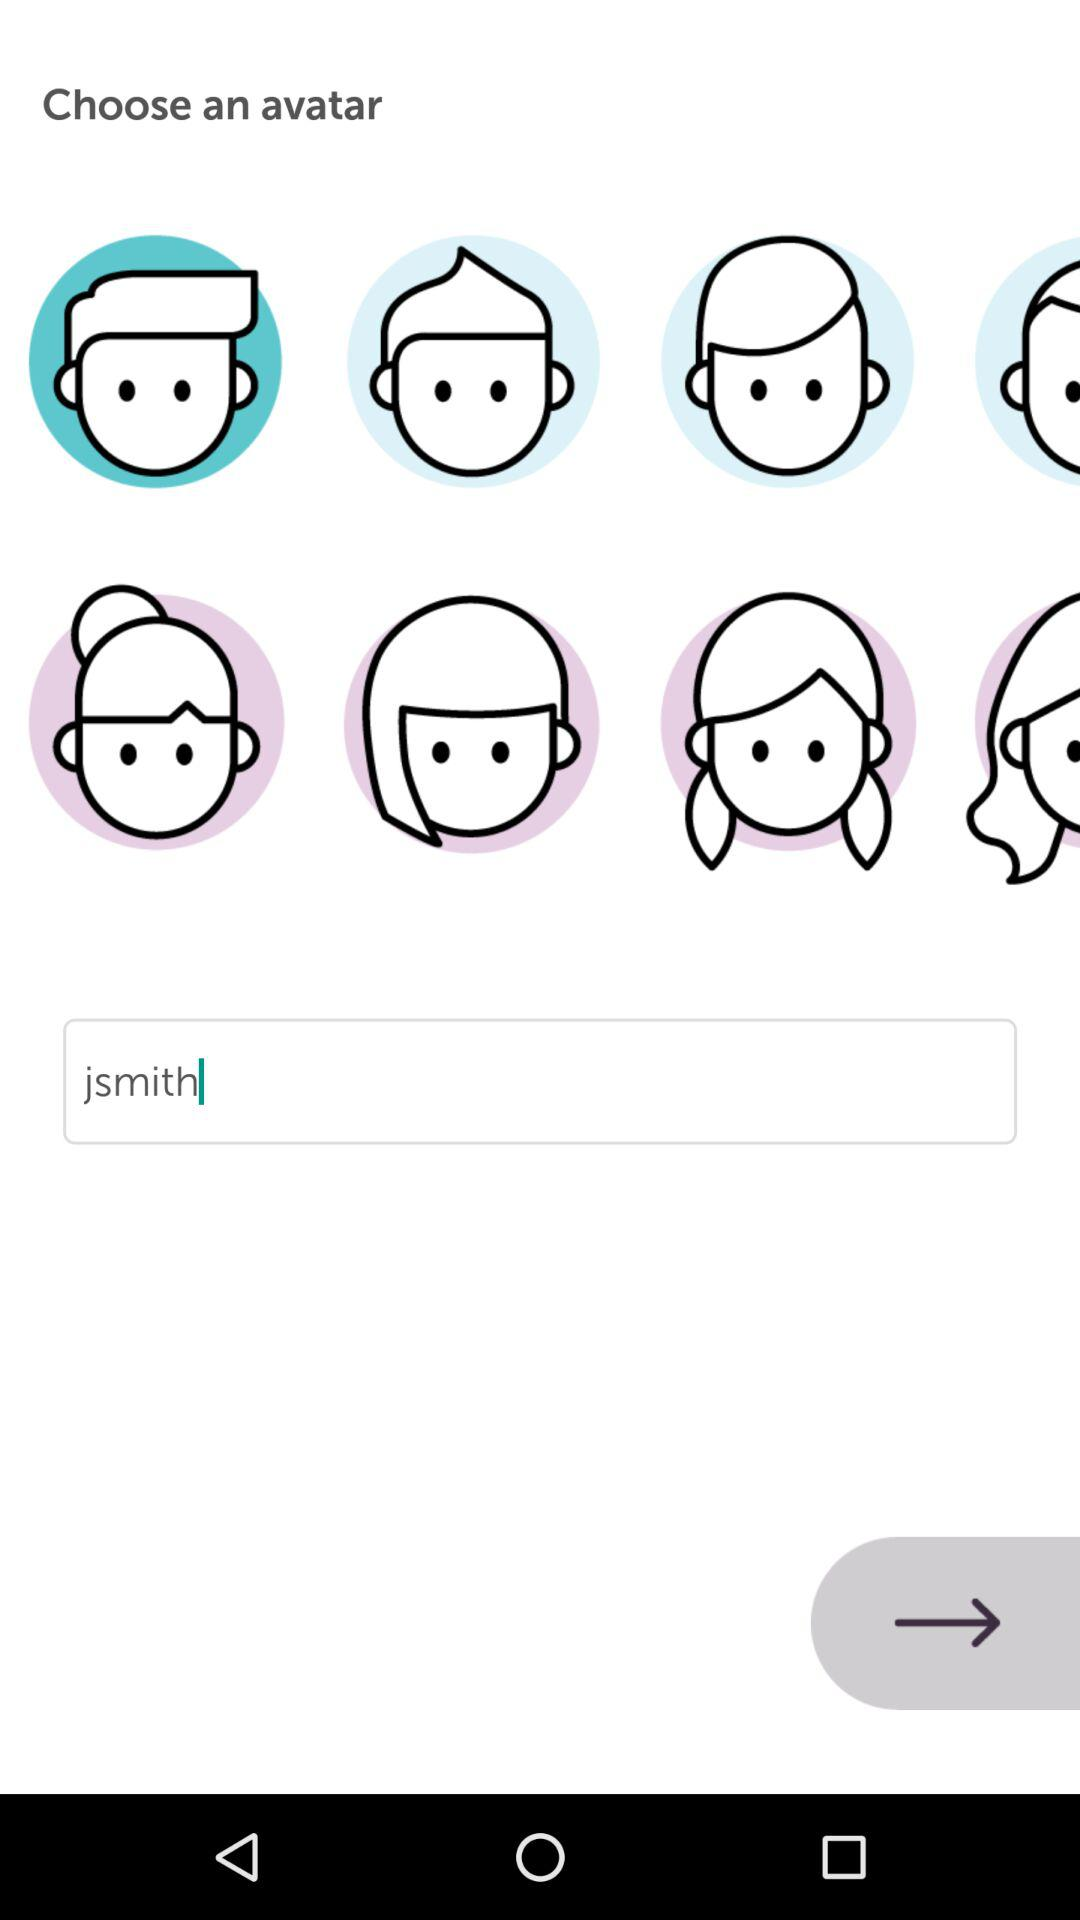How many avatar options are there?
Answer the question using a single word or phrase. 8 